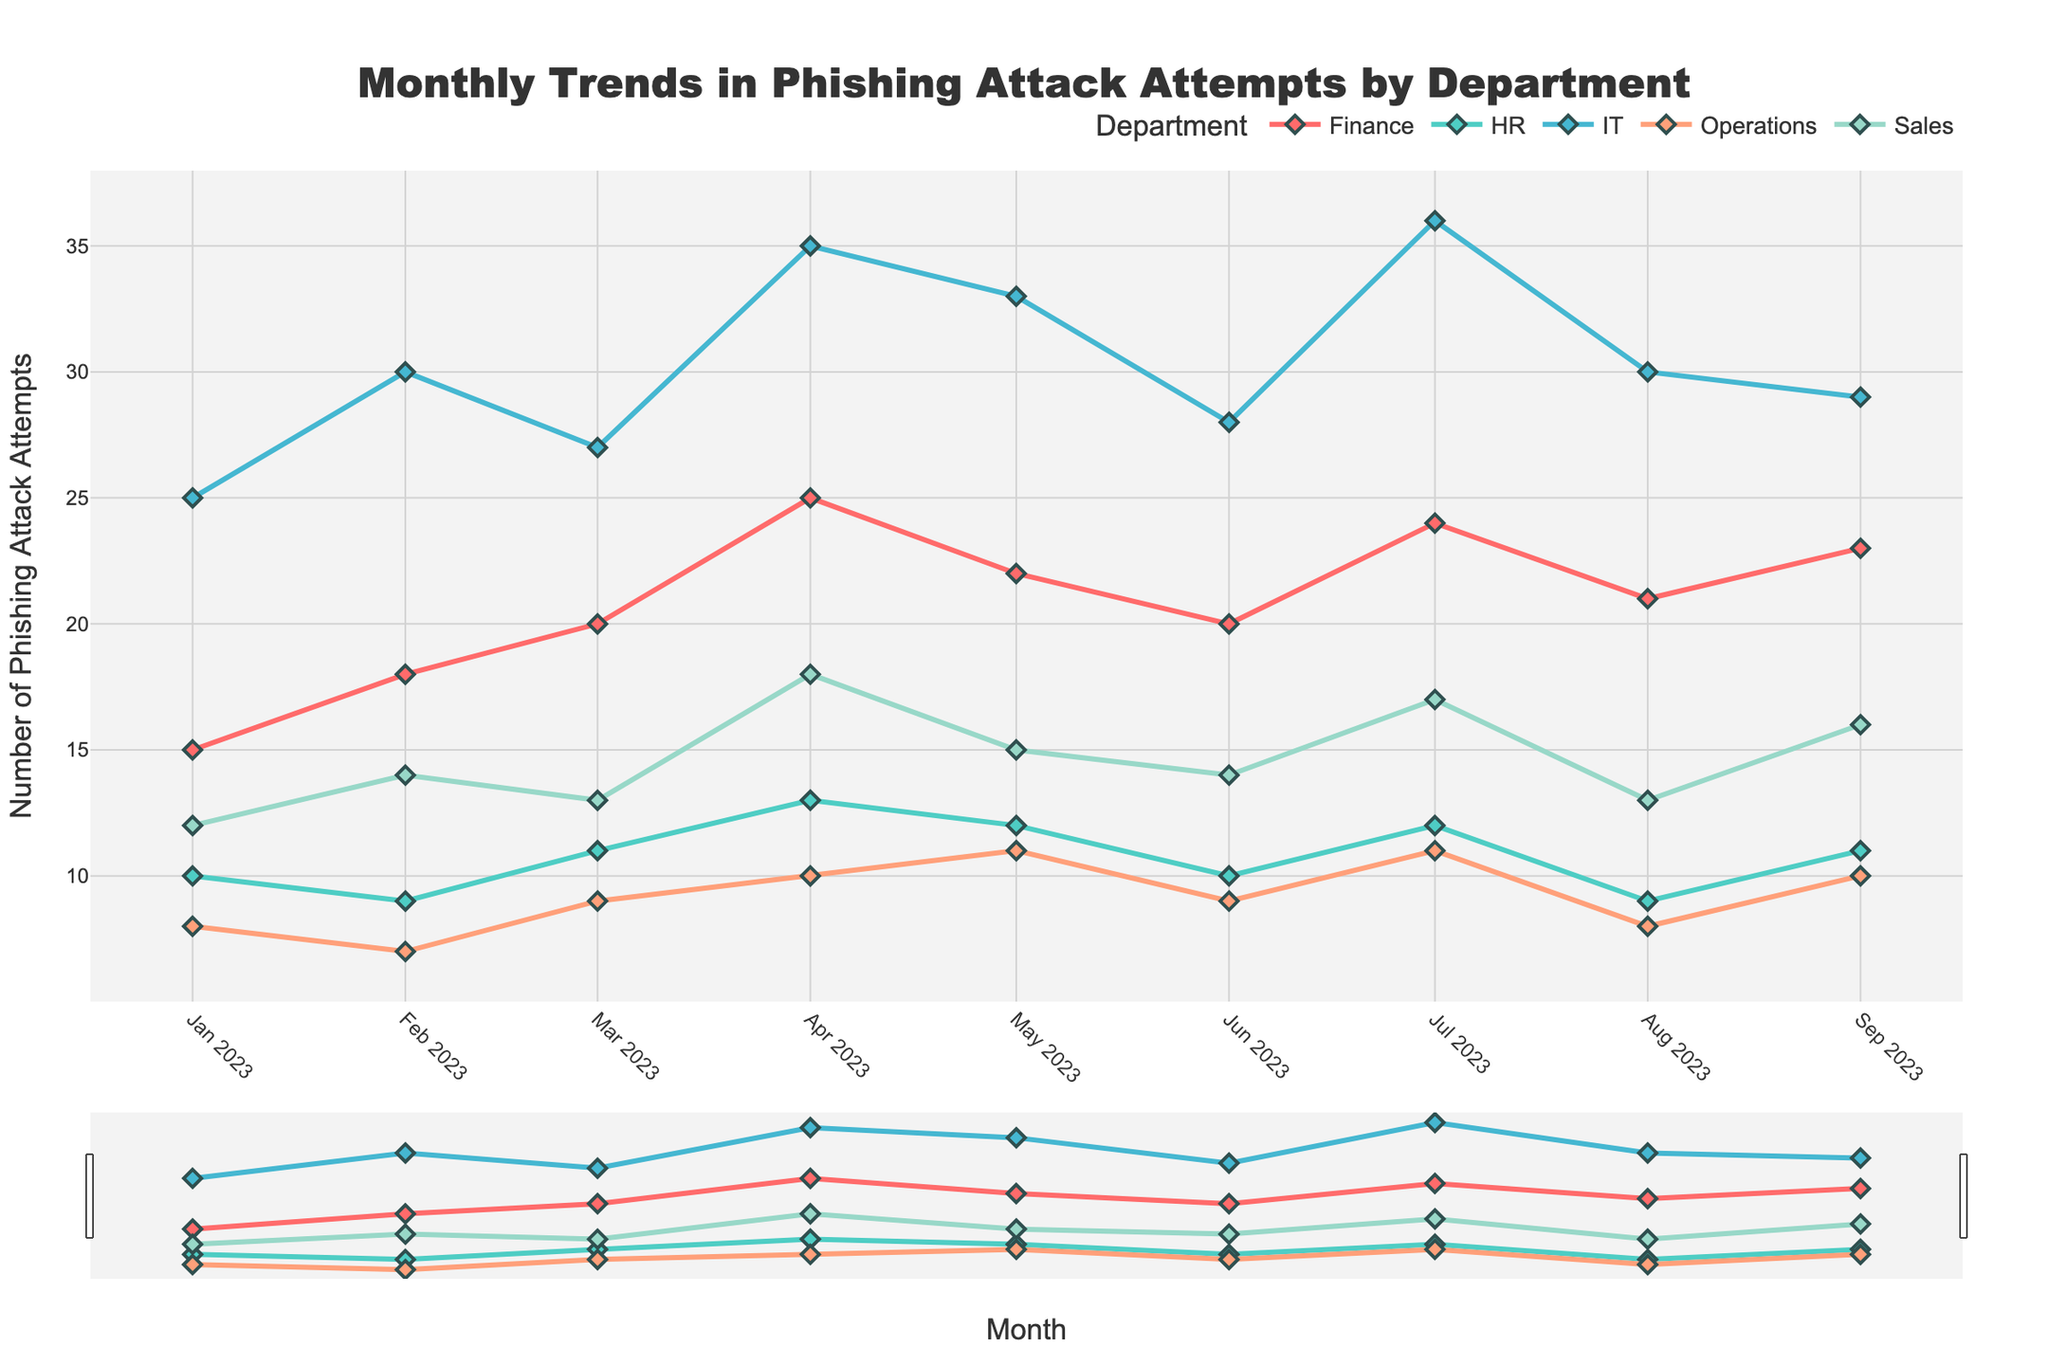What's the title of the figure? The title of the figure is usually displayed prominently at the top of the plot. In this case, the title is centered.
Answer: Monthly Trends in Phishing Attack Attempts by Department How many departments are represented in the plot? Each unique color corresponds to a different department. By counting the distinct colors or department labels in the legend, you can identify the number of departments.
Answer: 5 Which department had the highest number of phishing attack attempts in July 2023? Locate the month of July 2023 on the x-axis. Then, check which line reaches the highest point in that month.
Answer: IT What is the average number of phishing attack attempts in the Finance department from January to September 2023? Sum the attack attempts for the Finance department over these months (15+18+20+25+22+20+24+21+23), then divide by the number of months (9).
Answer: 20.9 Which month saw the highest total number of phishing attack attempts across all departments? For each month, sum the attack attempts across all departments. The month with the highest total is the one where this sum is greatest. Checking the sums: January (70), February (78), March (80), April (101), May (93), June (81), July (100), August (81), and September (89).
Answer: April In which month did the Sales department experience the most phishing attack attempts? Look at the Sales department's line across the months and identify the peak point.
Answer: April How did the number of phishing attack attempts in the IT department change from January to July 2023? Track the line for IT from January (25) to July (36). Compute the difference: 36 - 25.
Answer: Increased by 11 Which department had the least phishing attack attempts consistently every month? Compare the lines for each department across all months and identify which one stays consistently lower than the others.
Answer: Operations Calculate the difference in phishing attack attempts between the IT and HR departments in March 2023. Find the attack attempts for IT (27) and HR (11) in March, then subtract HR's from IT's: 27 - 11.
Answer: 16 Which department showed the most significant fluctuation in phishing attack attempts over the months? Identify the department whose line has the largest peaks and valleys, indicating a significant change from month to month. IT’s line shows significant variability.
Answer: IT 